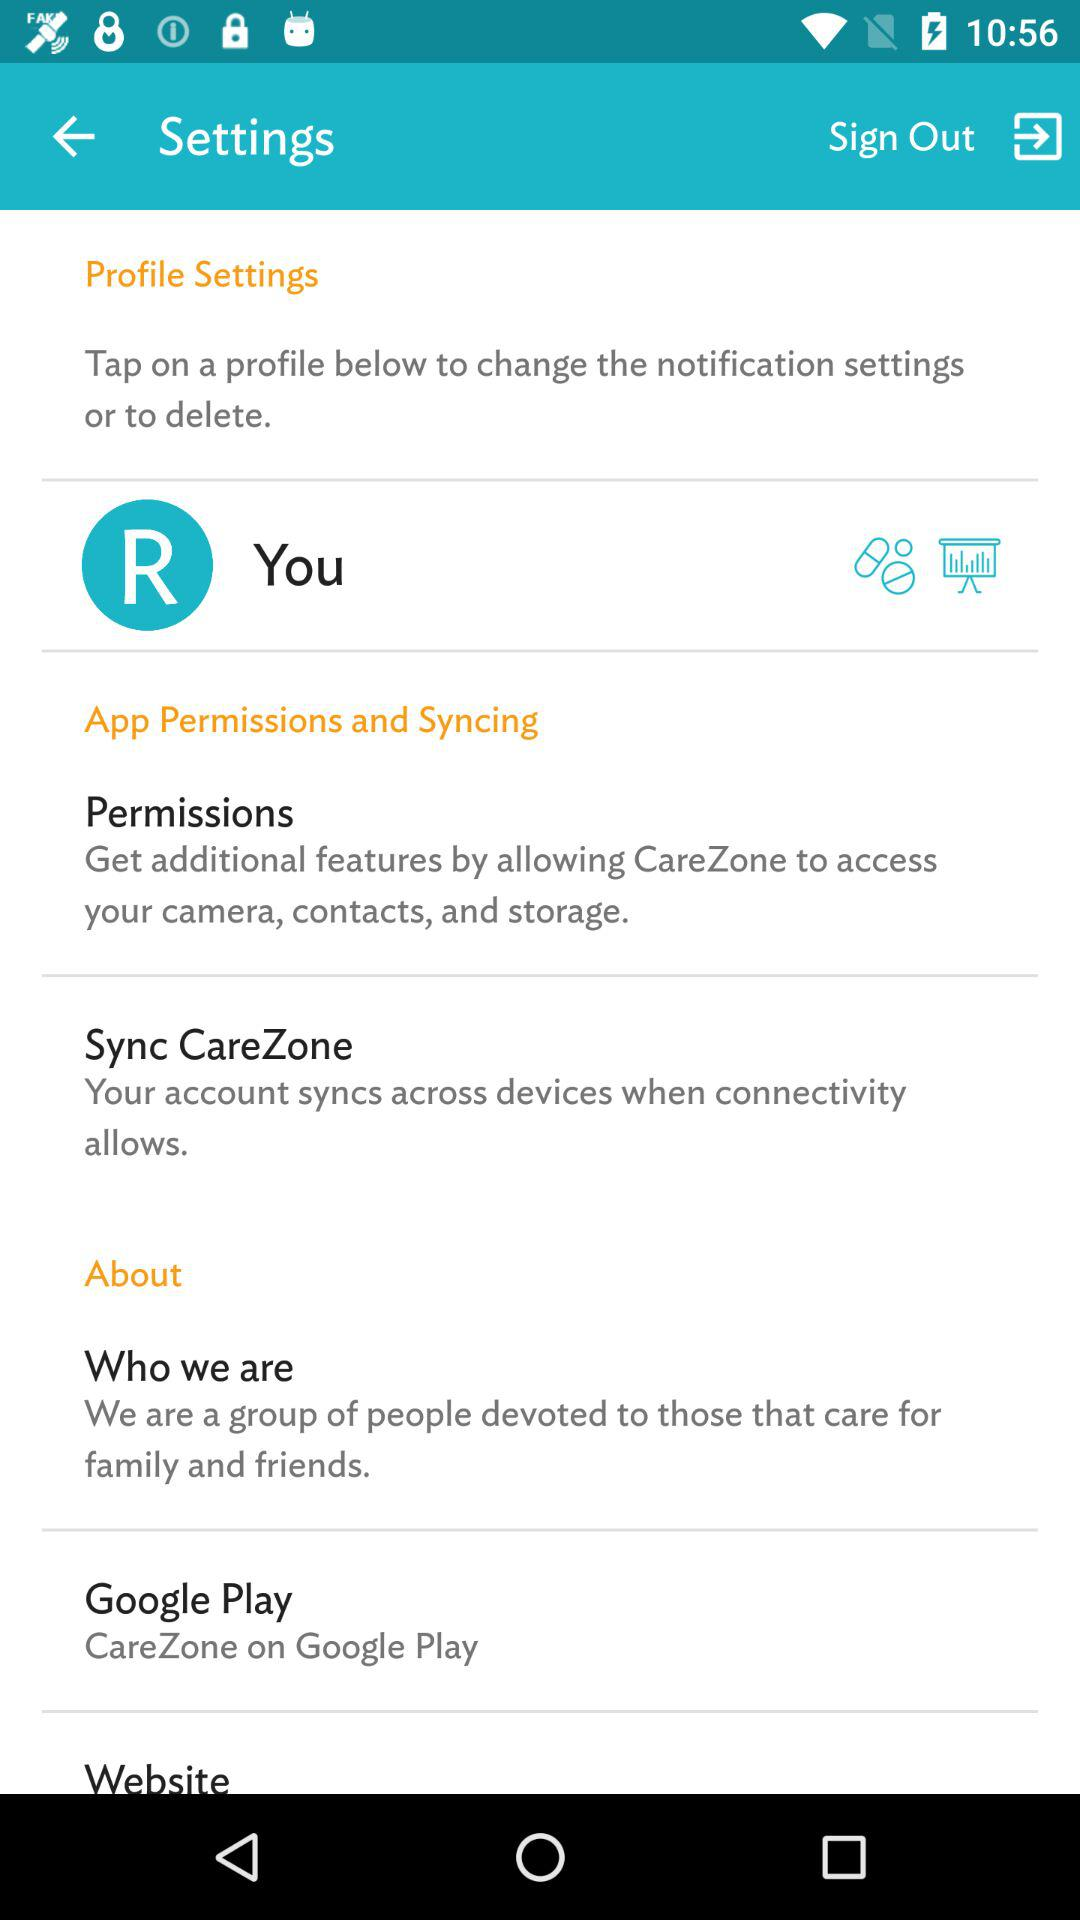What is the name of the application? The application names are "Google Play" and "CareZone". 